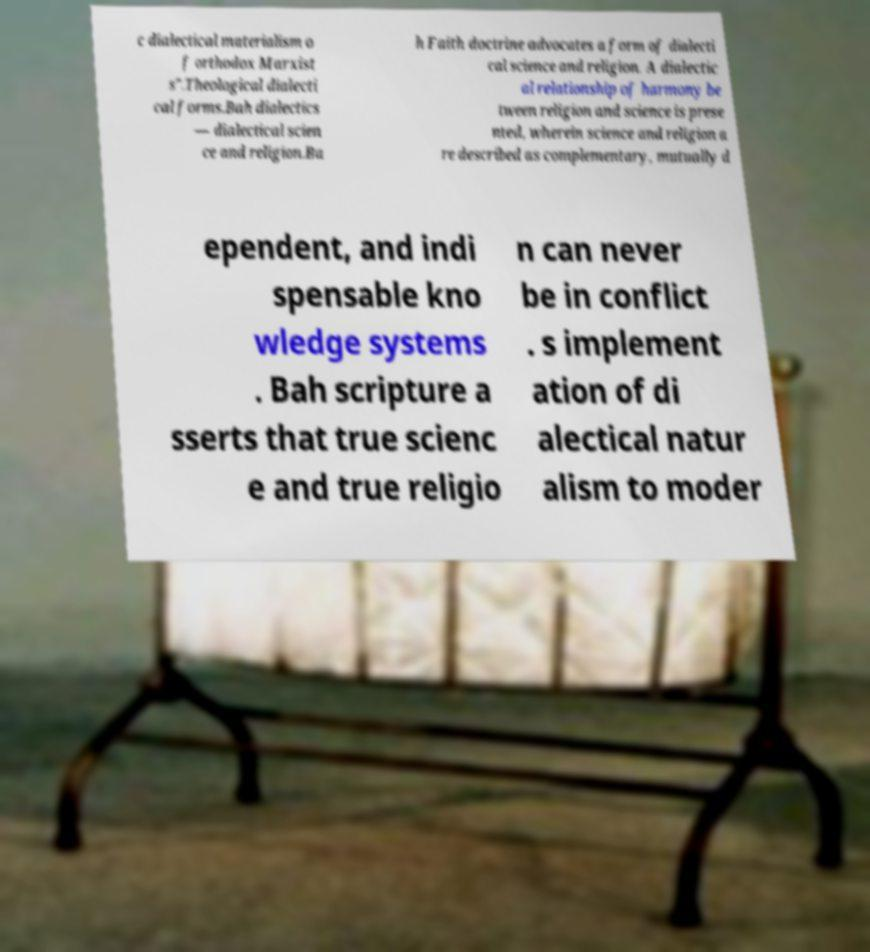What messages or text are displayed in this image? I need them in a readable, typed format. c dialectical materialism o f orthodox Marxist s".Theological dialecti cal forms.Bah dialectics — dialectical scien ce and religion.Ba h Faith doctrine advocates a form of dialecti cal science and religion. A dialectic al relationship of harmony be tween religion and science is prese nted, wherein science and religion a re described as complementary, mutually d ependent, and indi spensable kno wledge systems . Bah scripture a sserts that true scienc e and true religio n can never be in conflict . s implement ation of di alectical natur alism to moder 